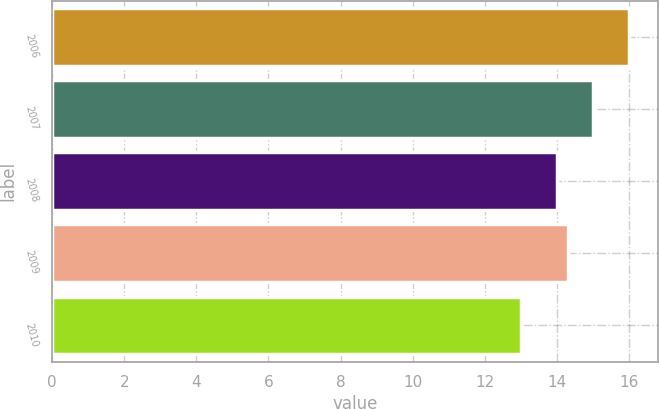Convert chart. <chart><loc_0><loc_0><loc_500><loc_500><bar_chart><fcel>2006<fcel>2007<fcel>2008<fcel>2009<fcel>2010<nl><fcel>16<fcel>15<fcel>14<fcel>14.3<fcel>13<nl></chart> 